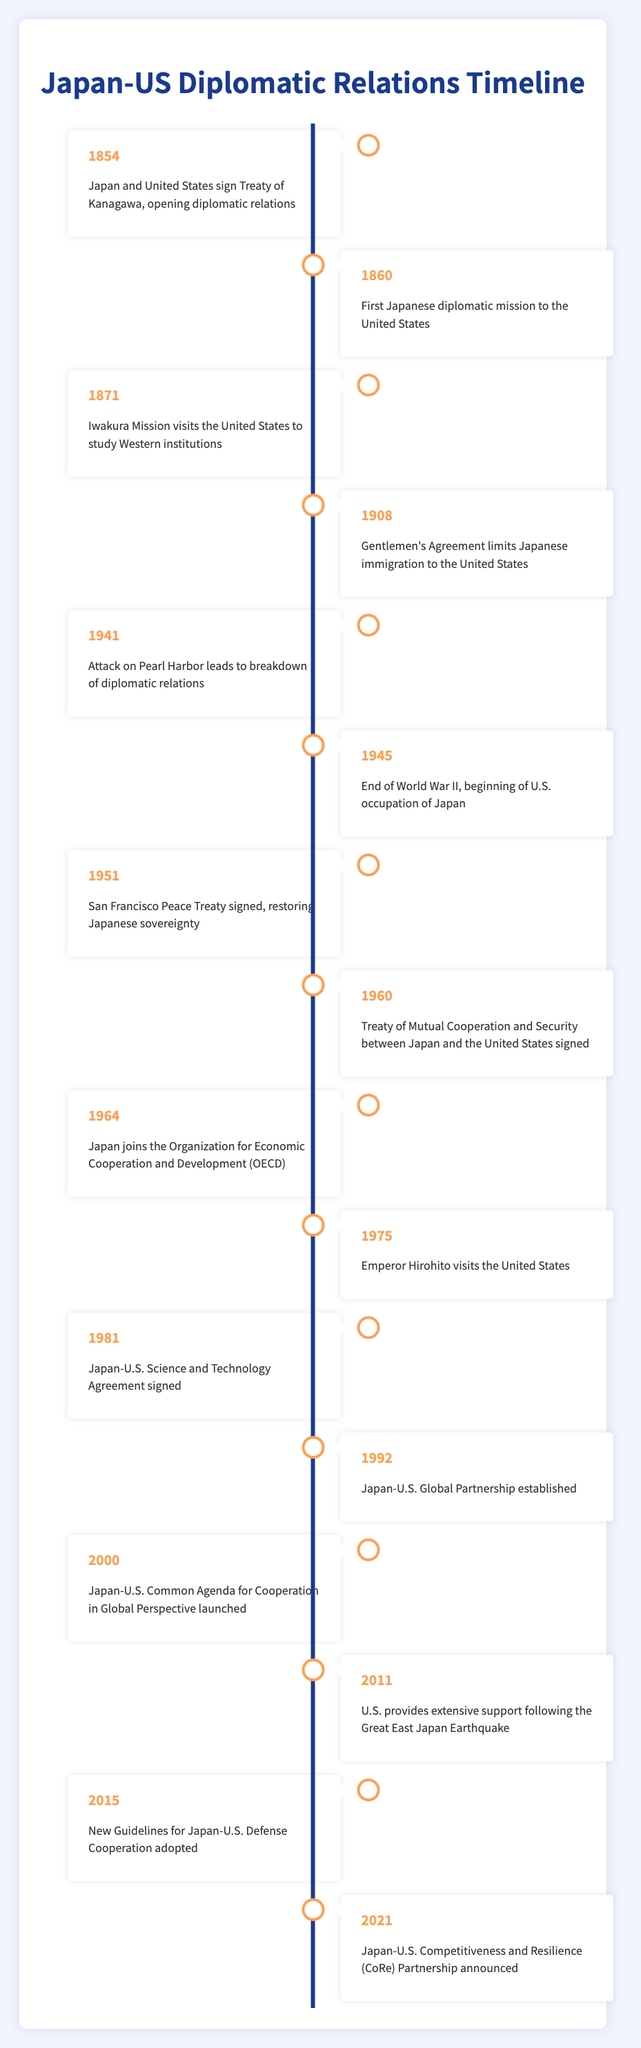What year did Japan and the United States sign the Treaty of Kanagawa? The Treaty of Kanagawa was signed in 1854, as stated in the first event of the timeline.
Answer: 1854 Which event marks the beginning of U.S. occupation of Japan? The event indicating the beginning of U.S. occupation of Japan is "End of World War II, beginning of U.S. occupation of Japan," which occurred in 1945.
Answer: 1945 What significant agreement was signed in 1960 between Japan and the United States? In 1960, the "Treaty of Mutual Cooperation and Security between Japan and the United States" was signed, as mentioned in the corresponding event in the timeline.
Answer: Treaty of Mutual Cooperation and Security Is the Japan-U.S. Global Partnership established before or after the Japan-U.S. Science and Technology Agreement? The Japan-U.S. Science and Technology Agreement was signed in 1981, and the Japan-U.S. Global Partnership was established in 1992, so the partnership was established after the agreement.
Answer: After What is the difference in years between the signing of the Treaty of Kanagawa and the Japan-U.S. Common Agenda for Cooperation in Global Perspective? The Treaty of Kanagawa was signed in 1854, and the Common Agenda was launched in 2000. The difference is calculated as 2000 - 1854 = 146 years.
Answer: 146 years How many events related to diplomatic relations occurred in the 20th century based on this timeline? The events within the 20th century are listed from 1908 to 2000, which gives us a total of 10 events in the 20th century: 1908, 1941, 1945, 1951, 1960, 1964, 1975, 1981, 1992, and 2000.
Answer: 10 events Was there a breakdown of diplomatic relations due to an attack before or after the end of World War II? The breakdown of diplomatic relations due to the Attack on Pearl Harbor occurred in 1941, while World War II ended in 1945. Thus, the breakdown occurred before the end of the war.
Answer: Before What is the significance of the event that took place in 2011? The event in 2011, where the U.S. provided extensive support following the Great East Japan Earthquake, signifies a collaborative and supportive relationship during a humanitarian crisis, showcasing diplomatic ties beyond formal agreements.
Answer: Humanitarian support after an earthquake 